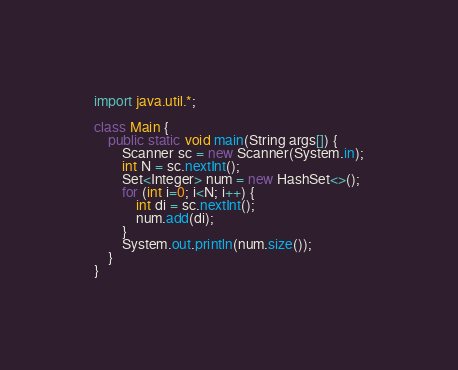<code> <loc_0><loc_0><loc_500><loc_500><_Java_>import java.util.*;

class Main {
    public static void main(String args[]) {
        Scanner sc = new Scanner(System.in);
        int N = sc.nextInt();
        Set<Integer> num = new HashSet<>();
        for (int i=0; i<N; i++) {
            int di = sc.nextInt();
            num.add(di);
        }
        System.out.println(num.size());
    }
}
</code> 